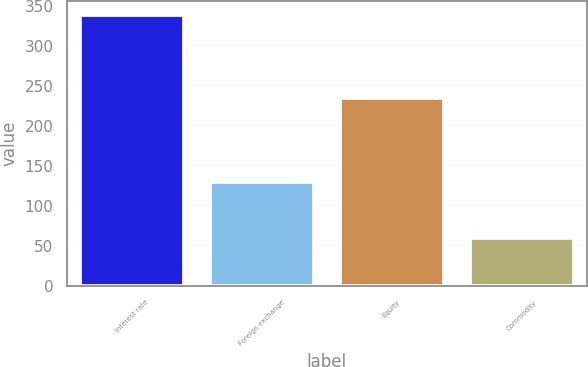Convert chart. <chart><loc_0><loc_0><loc_500><loc_500><bar_chart><fcel>Interest rate<fcel>Foreign exchange<fcel>Equity<fcel>Commodity<nl><fcel>339<fcel>130<fcel>235<fcel>60<nl></chart> 